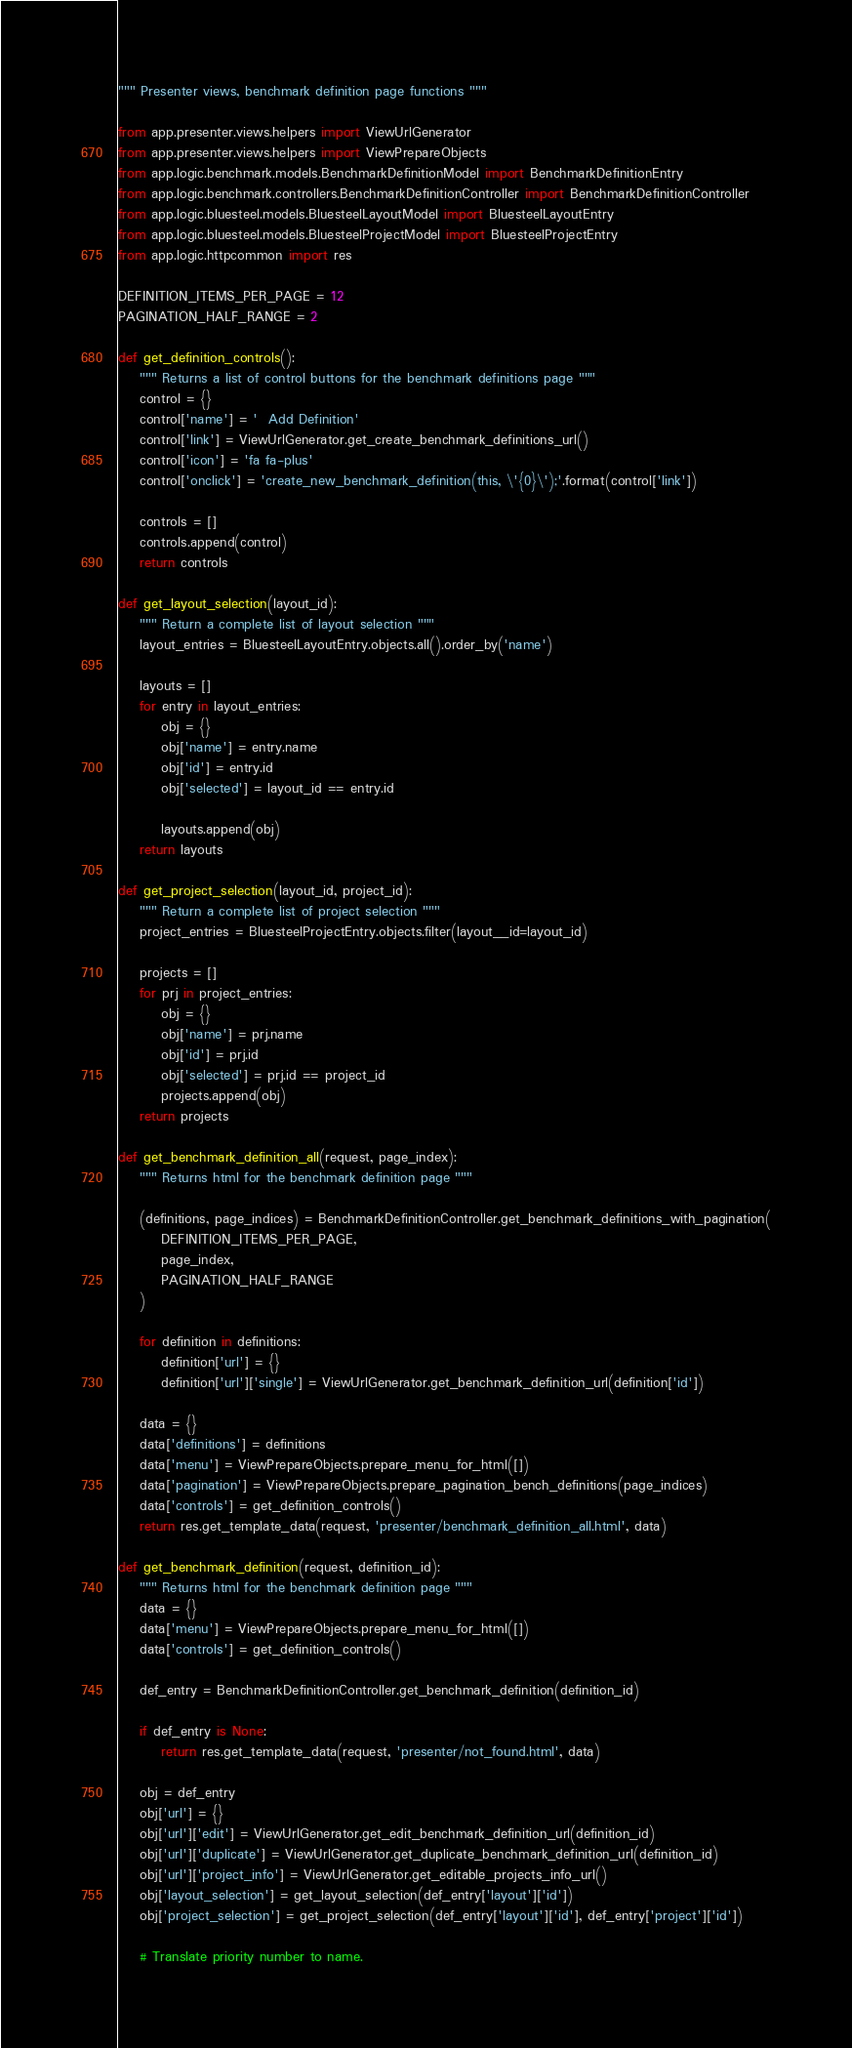Convert code to text. <code><loc_0><loc_0><loc_500><loc_500><_Python_>""" Presenter views, benchmark definition page functions """

from app.presenter.views.helpers import ViewUrlGenerator
from app.presenter.views.helpers import ViewPrepareObjects
from app.logic.benchmark.models.BenchmarkDefinitionModel import BenchmarkDefinitionEntry
from app.logic.benchmark.controllers.BenchmarkDefinitionController import BenchmarkDefinitionController
from app.logic.bluesteel.models.BluesteelLayoutModel import BluesteelLayoutEntry
from app.logic.bluesteel.models.BluesteelProjectModel import BluesteelProjectEntry
from app.logic.httpcommon import res

DEFINITION_ITEMS_PER_PAGE = 12
PAGINATION_HALF_RANGE = 2

def get_definition_controls():
    """ Returns a list of control buttons for the benchmark definitions page """
    control = {}
    control['name'] = '  Add Definition'
    control['link'] = ViewUrlGenerator.get_create_benchmark_definitions_url()
    control['icon'] = 'fa fa-plus'
    control['onclick'] = 'create_new_benchmark_definition(this, \'{0}\');'.format(control['link'])

    controls = []
    controls.append(control)
    return controls

def get_layout_selection(layout_id):
    """ Return a complete list of layout selection """
    layout_entries = BluesteelLayoutEntry.objects.all().order_by('name')

    layouts = []
    for entry in layout_entries:
        obj = {}
        obj['name'] = entry.name
        obj['id'] = entry.id
        obj['selected'] = layout_id == entry.id

        layouts.append(obj)
    return layouts

def get_project_selection(layout_id, project_id):
    """ Return a complete list of project selection """
    project_entries = BluesteelProjectEntry.objects.filter(layout__id=layout_id)

    projects = []
    for prj in project_entries:
        obj = {}
        obj['name'] = prj.name
        obj['id'] = prj.id
        obj['selected'] = prj.id == project_id
        projects.append(obj)
    return projects

def get_benchmark_definition_all(request, page_index):
    """ Returns html for the benchmark definition page """

    (definitions, page_indices) = BenchmarkDefinitionController.get_benchmark_definitions_with_pagination(
        DEFINITION_ITEMS_PER_PAGE,
        page_index,
        PAGINATION_HALF_RANGE
    )

    for definition in definitions:
        definition['url'] = {}
        definition['url']['single'] = ViewUrlGenerator.get_benchmark_definition_url(definition['id'])

    data = {}
    data['definitions'] = definitions
    data['menu'] = ViewPrepareObjects.prepare_menu_for_html([])
    data['pagination'] = ViewPrepareObjects.prepare_pagination_bench_definitions(page_indices)
    data['controls'] = get_definition_controls()
    return res.get_template_data(request, 'presenter/benchmark_definition_all.html', data)

def get_benchmark_definition(request, definition_id):
    """ Returns html for the benchmark definition page """
    data = {}
    data['menu'] = ViewPrepareObjects.prepare_menu_for_html([])
    data['controls'] = get_definition_controls()

    def_entry = BenchmarkDefinitionController.get_benchmark_definition(definition_id)

    if def_entry is None:
        return res.get_template_data(request, 'presenter/not_found.html', data)

    obj = def_entry
    obj['url'] = {}
    obj['url']['edit'] = ViewUrlGenerator.get_edit_benchmark_definition_url(definition_id)
    obj['url']['duplicate'] = ViewUrlGenerator.get_duplicate_benchmark_definition_url(definition_id)
    obj['url']['project_info'] = ViewUrlGenerator.get_editable_projects_info_url()
    obj['layout_selection'] = get_layout_selection(def_entry['layout']['id'])
    obj['project_selection'] = get_project_selection(def_entry['layout']['id'], def_entry['project']['id'])

    # Translate priority number to name.</code> 